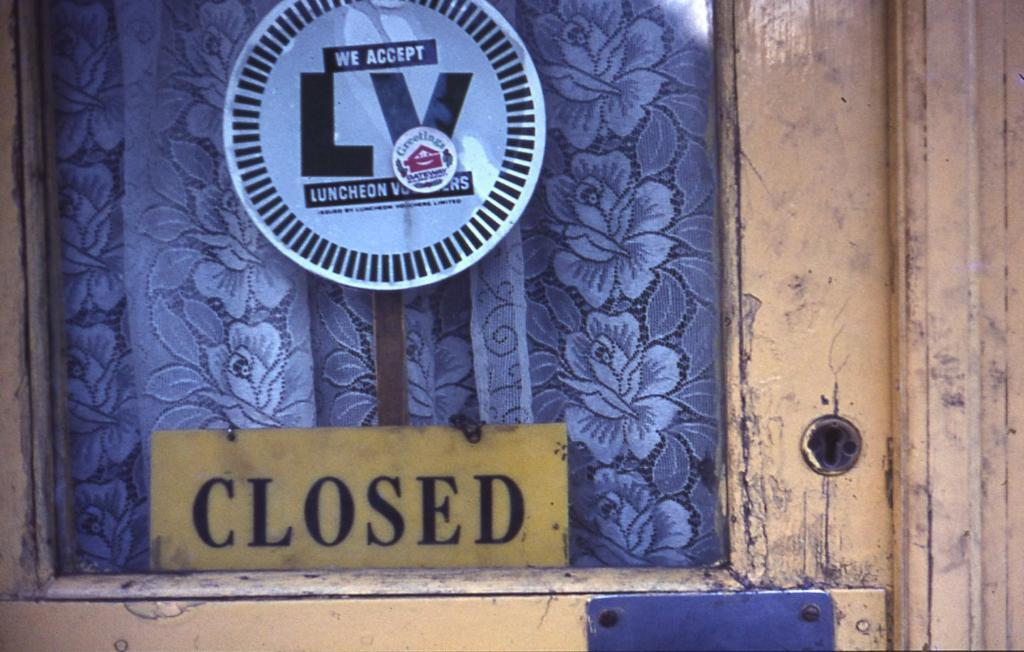<image>
Render a clear and concise summary of the photo. A sign in the window says the establishment accepts lunch vouchers, but is closed. 